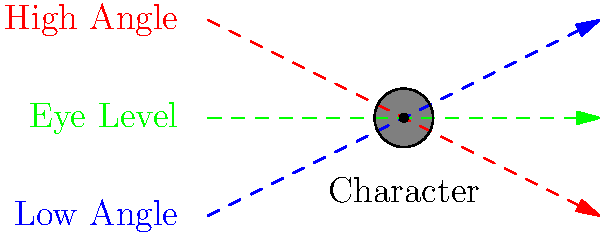Analyze the camera angles depicted in the diagram above, typically used in video game cutscenes. How might each angle affect the viewer's perception of the character, and which angle would be most effective for portraying the character as powerful and dominant? To answer this question, let's break down the effects of each camera angle:

1. Low Angle (Blue):
   - Camera is positioned below the character, looking up.
   - Effect: Makes the character appear larger, more imposing, and powerful.
   - Often used to convey dominance, strength, or heroism.

2. High Angle (Red):
   - Camera is positioned above the character, looking down.
   - Effect: Makes the character appear smaller, vulnerable, or insignificant.
   - Often used to show weakness, inferiority, or danger.

3. Eye Level (Green):
   - Camera is at the same level as the character's eyes.
   - Effect: Neutral perspective, creates a sense of equality between viewer and character.
   - Often used for normal dialogue or to establish a connection with the character.

Considering the goal of portraying the character as powerful and dominant, the low angle would be most effective. This angle makes the character appear larger than life, towering over the viewer, which reinforces their strength and authority.

In video game cutscenes, these angles are often used dynamically to enhance storytelling:
- A low angle might be used when introducing a boss character or showcasing a hero's triumph.
- A high angle could depict a character in peril or show a villain looking down on their victims.
- Eye level shots are common for dialogue scenes to create a sense of connection with the player.

The choice of angle significantly impacts the visual storytelling and can subtly influence the player's emotional response to characters and events in the game.
Answer: Low angle, as it makes the character appear larger and more imposing, effectively conveying power and dominance. 